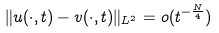<formula> <loc_0><loc_0><loc_500><loc_500>\| u ( \cdot , t ) - v ( \cdot , t ) \| _ { L ^ { 2 } } = o ( t ^ { - \frac { N } { 4 } } )</formula> 